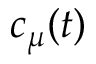Convert formula to latex. <formula><loc_0><loc_0><loc_500><loc_500>c _ { \mu } ( t )</formula> 